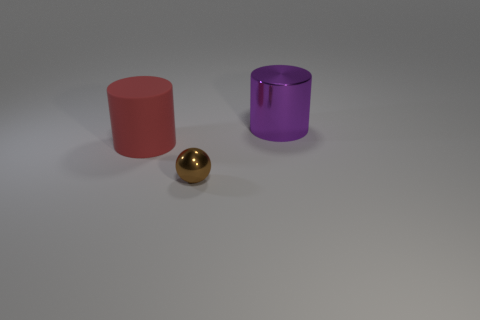Add 1 gray cylinders. How many objects exist? 4 Subtract all spheres. How many objects are left? 2 Add 2 blue rubber balls. How many blue rubber balls exist? 2 Subtract 0 red cubes. How many objects are left? 3 Subtract all tiny yellow things. Subtract all purple metal cylinders. How many objects are left? 2 Add 3 large rubber cylinders. How many large rubber cylinders are left? 4 